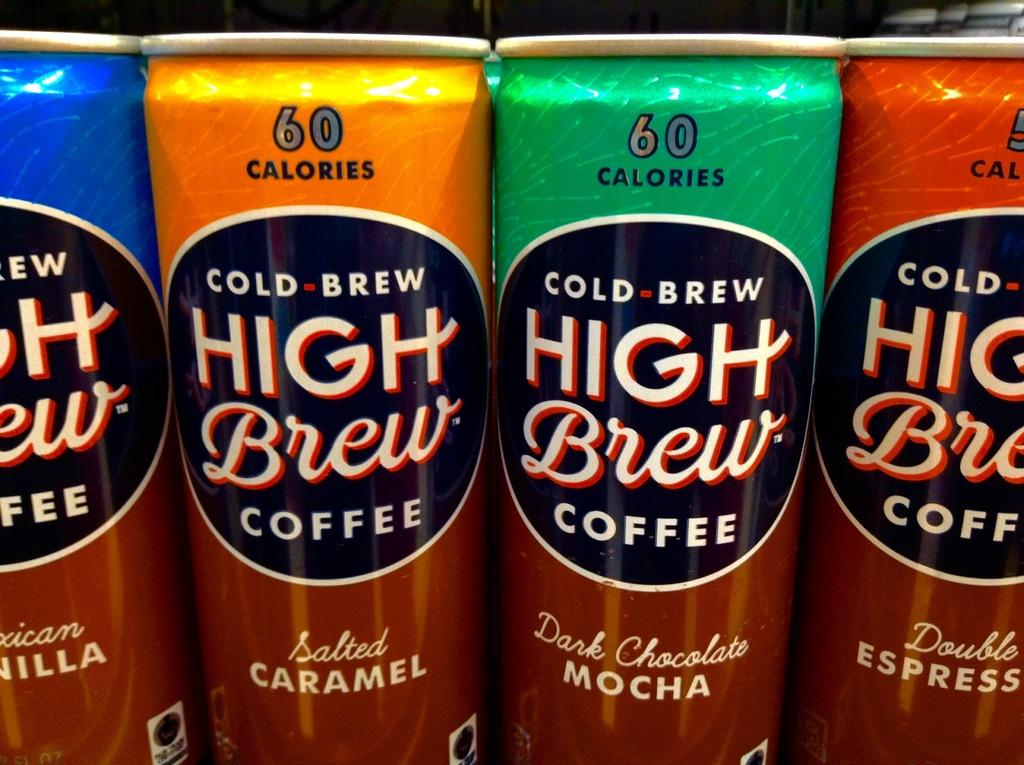<image>
Describe the image concisely. Cans of High Brew Coffee in different flavors 